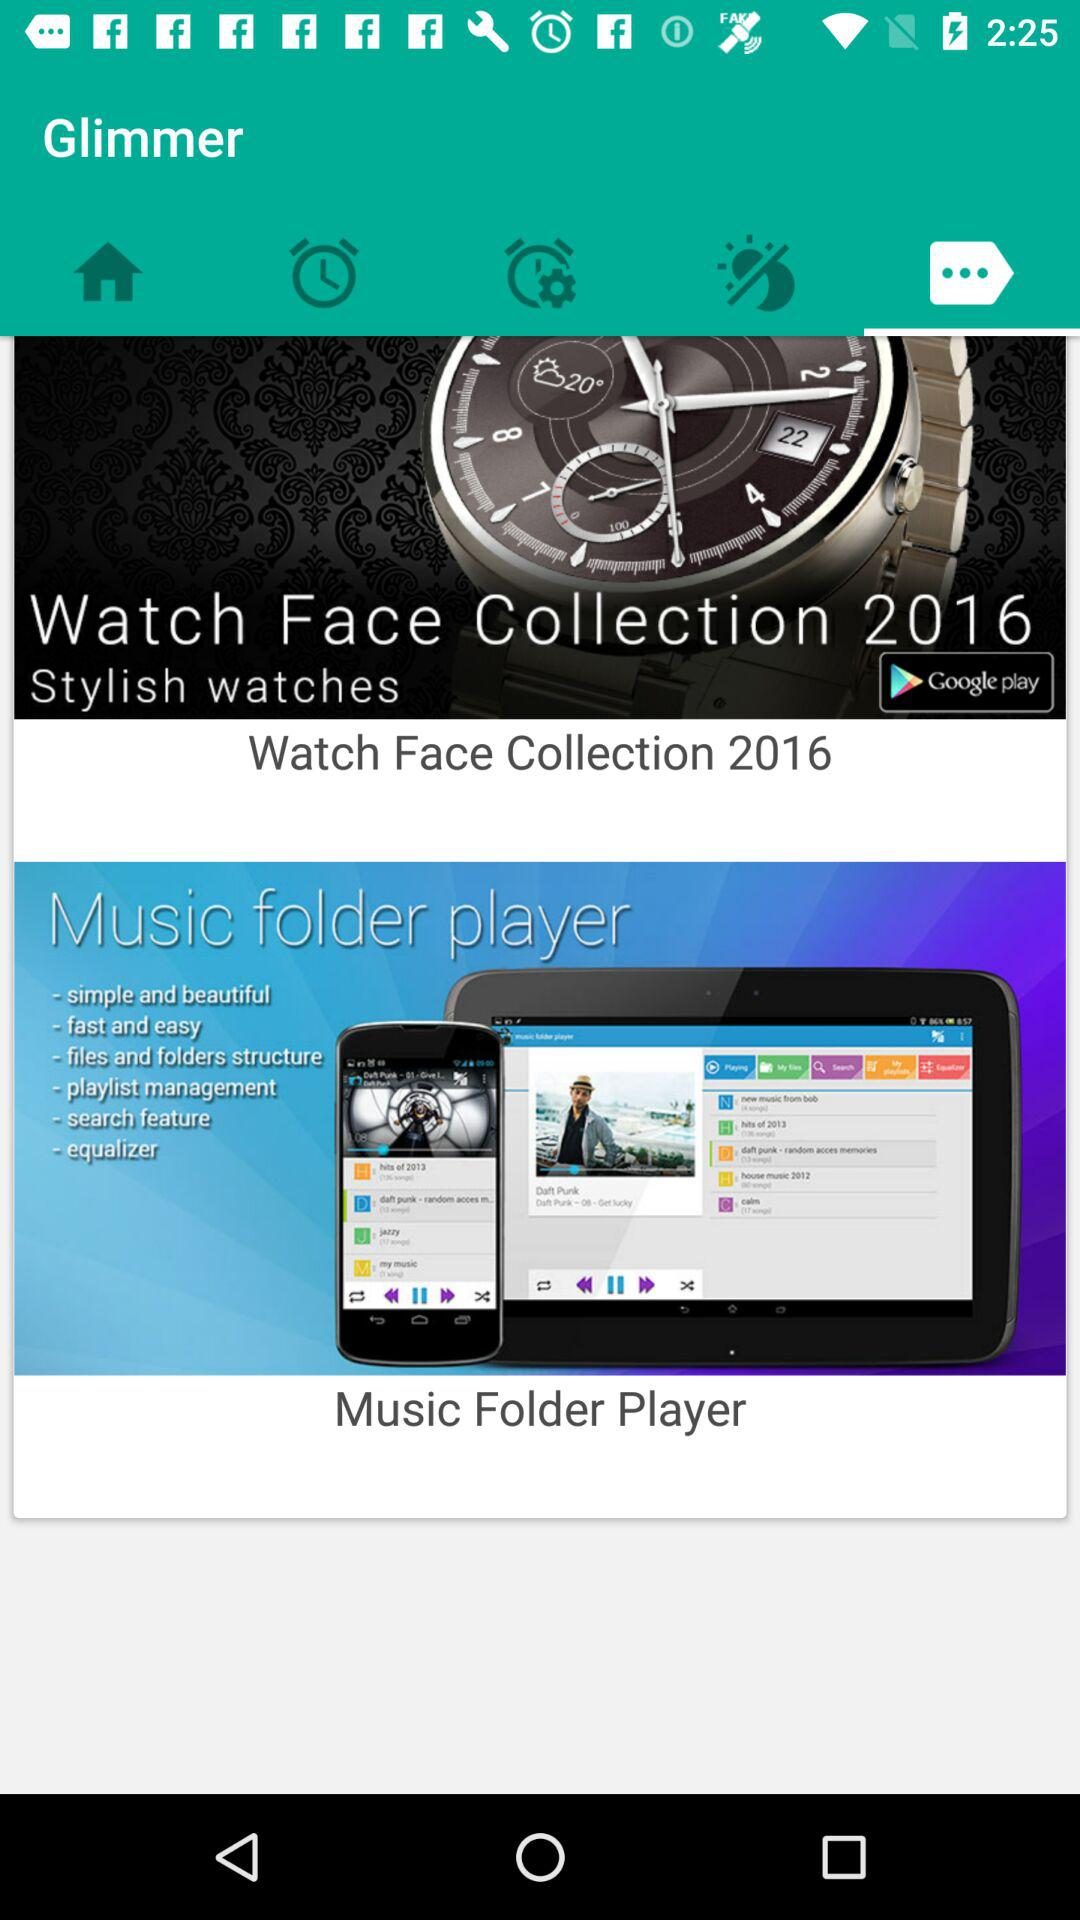What are the features of Music folder player? The features are "simple and beautiful", "fast and easy", "files and folders structure", "playlist management", "search feature" and "equalizer". 